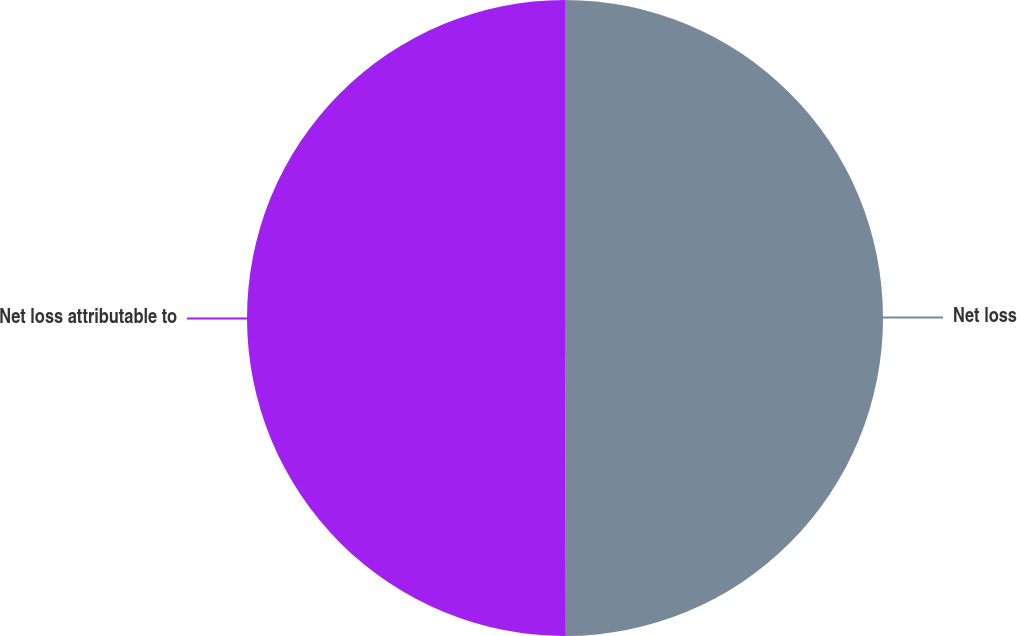Convert chart to OTSL. <chart><loc_0><loc_0><loc_500><loc_500><pie_chart><fcel>Net loss<fcel>Net loss attributable to<nl><fcel>49.96%<fcel>50.04%<nl></chart> 